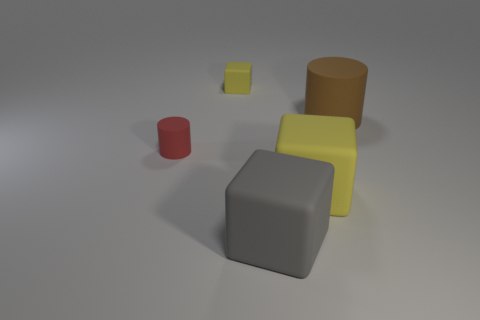There is a tiny object that is to the left of the small rubber thing behind the small red matte object; what shape is it? cylinder 